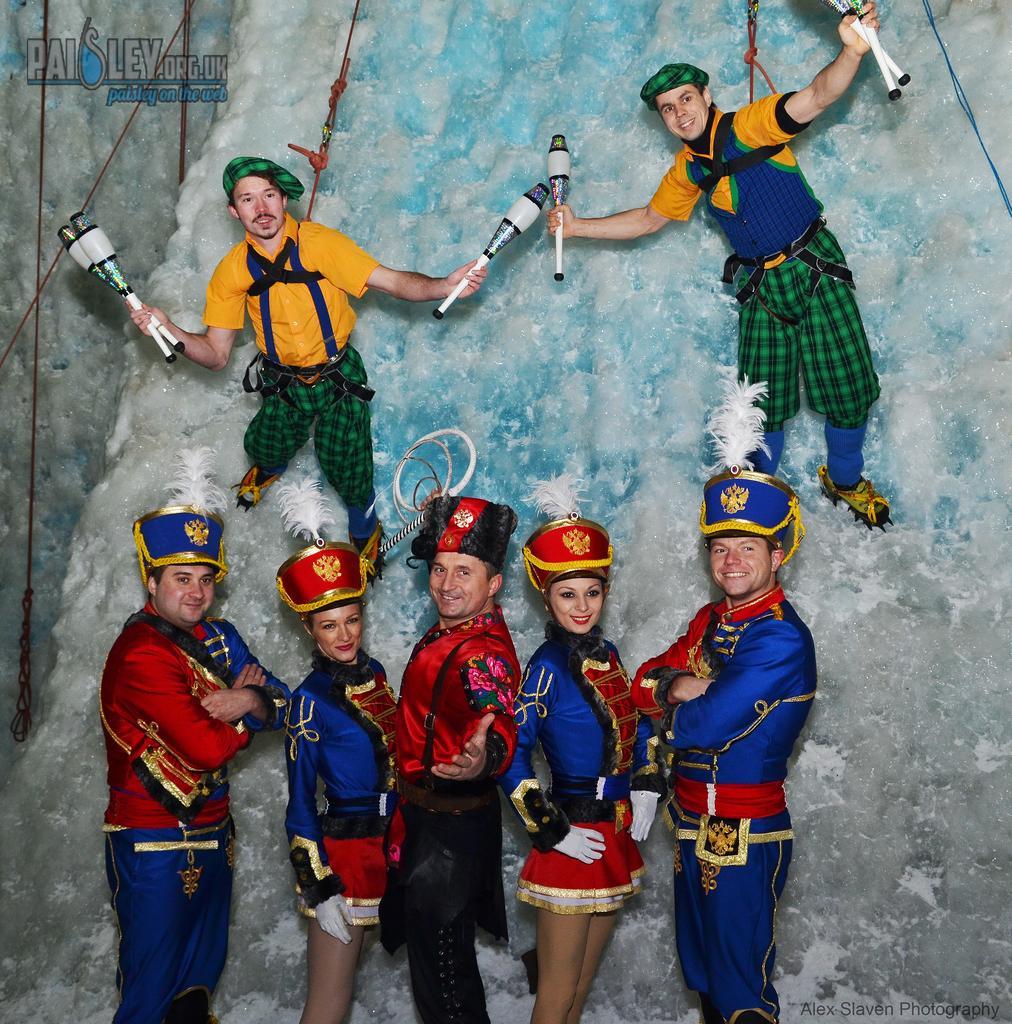Please provide a concise description of this image. These five people are standing. These two people are holding objects. Top of the image there is a watermark. 